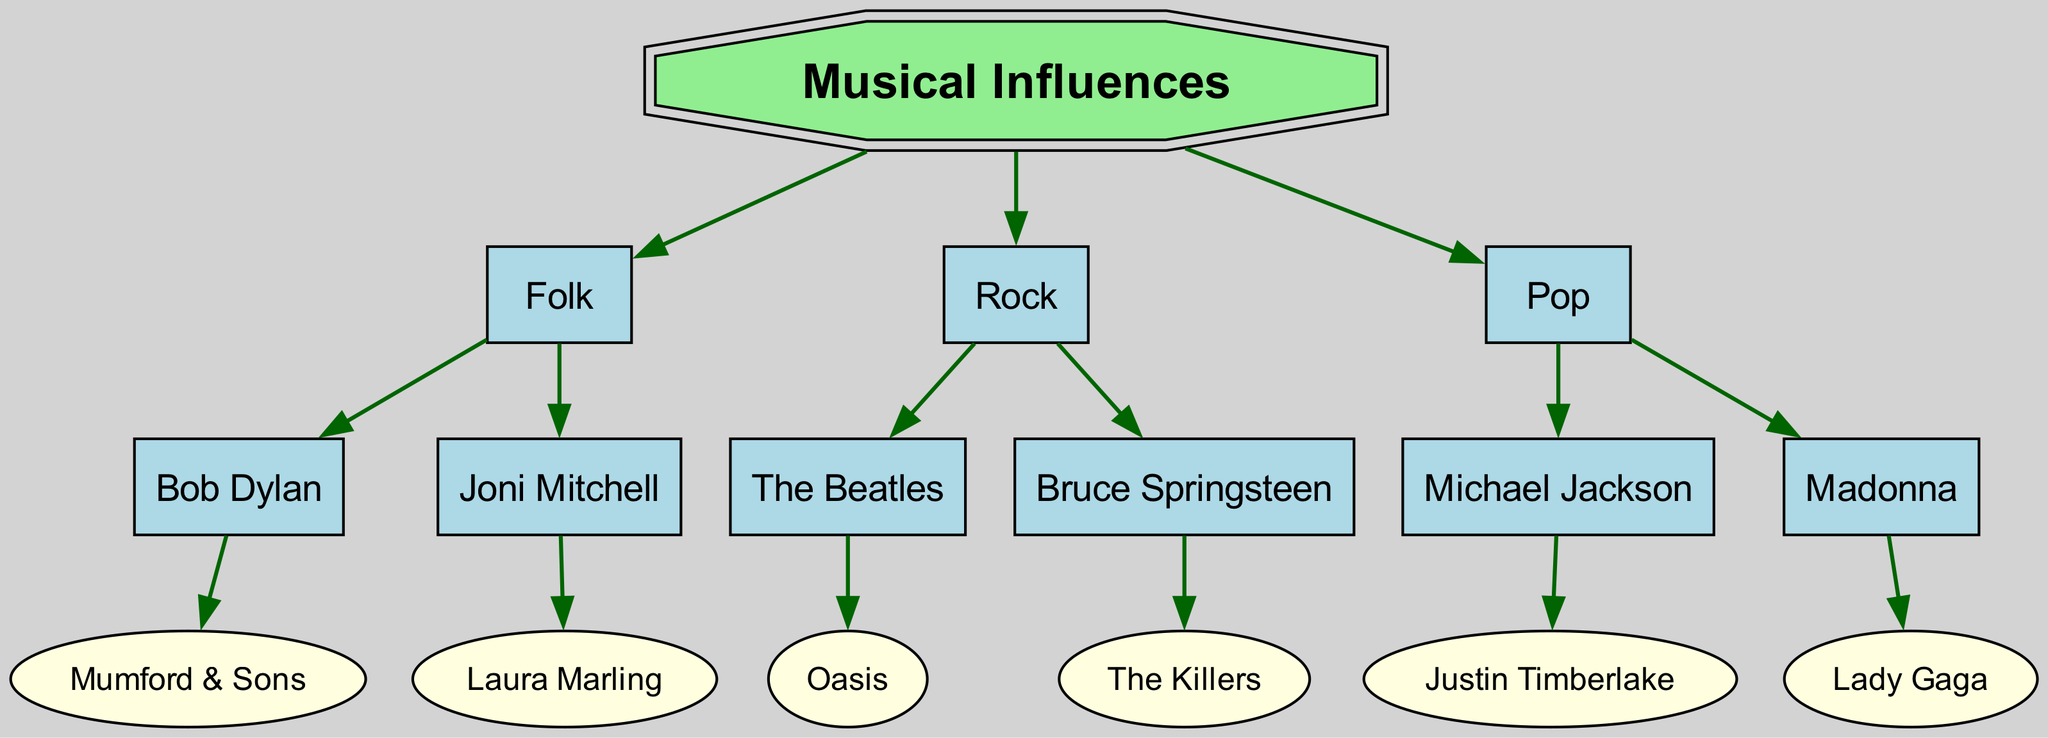What is the root of the diagram? The root of the diagram is the central concept, which is labeled as "Musical Influences". This is typically represented at the top or center of a family tree diagram.
Answer: Musical Influences How many main genres are represented? By examining the children of the root node, we can see there are three main genres listed: Folk, Rock, and Pop. This is counted directly from the items under "Musical Influences".
Answer: 3 Who is a child of Bob Dylan? Looking at the children of Bob Dylan, we observe that Mumford & Sons is listed directly underneath him. This shows the direct musical influence evident in the diagram.
Answer: Mumford & Sons Which genre includes The Killers? The Killers are found as a child under Bruce Springsteen, who is categorized under the Rock genre. By identifying the connections, we can see which genre they belong to based on the hierarchical structure.
Answer: Rock How many artists are influenced by Joni Mitchell? By examining Joni Mitchell's children, we see there is one artist listed, which is Laura Marling. Hence, we can determine the total count from the direct connections shown in the diagram.
Answer: 1 Which two artists are directly influenced by Madonna? The children under Madonna include one artist, which is Lady Gaga. As there’s only one direct influence listed, we can state that Madonna influences only her child in this case.
Answer: Lady Gaga What is the relationship between Bruce Springsteen and The Killers? Bruce Springsteen is identified as a parent to The Killers, showcasing a direct influence relationship where Springsteen is represented as an earlier generation that influences the subsequent generation, namely The Killers.
Answer: Parent-Child From which genre does Laura Marling descend? Laura Marling is directly beneath Joni Mitchell in the family tree. Since Joni Mitchell is categorized under Folk, it follows that Laura Marling is descended from the Folk genre.
Answer: Folk How many children does Michael Jackson have in the diagram? Michael Jackson has one child listed, which is Justin Timberlake. By assessing the connections shown underneath him, we can derive the total number of children he has in the context of this diagram.
Answer: 1 